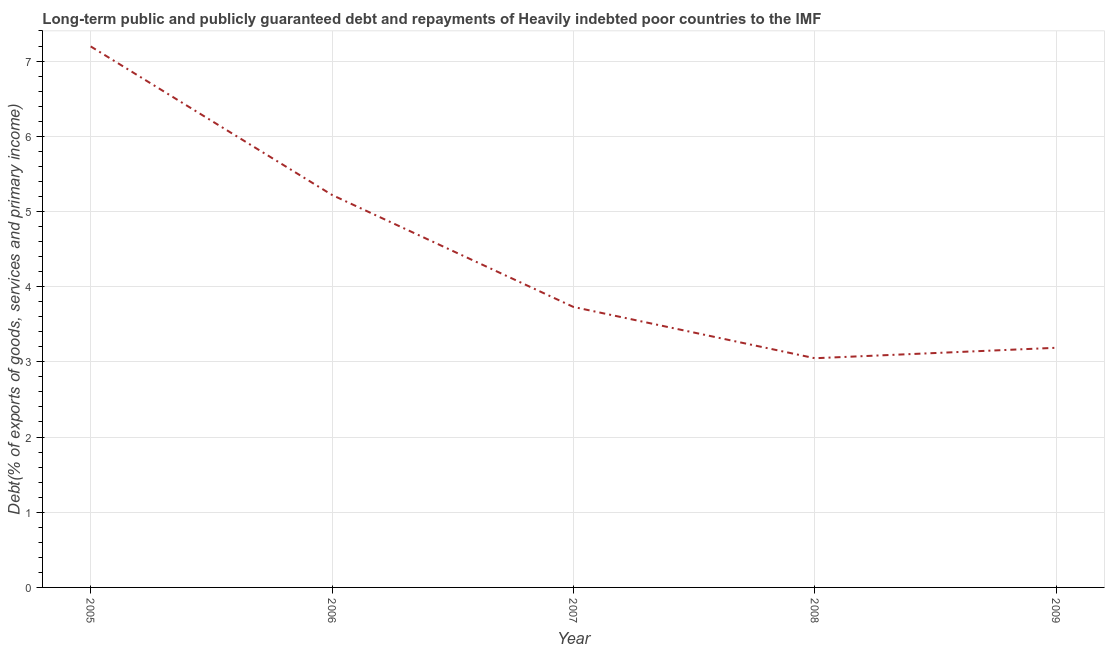What is the debt service in 2005?
Offer a very short reply. 7.19. Across all years, what is the maximum debt service?
Offer a terse response. 7.19. Across all years, what is the minimum debt service?
Make the answer very short. 3.05. What is the sum of the debt service?
Provide a short and direct response. 22.38. What is the difference between the debt service in 2005 and 2009?
Ensure brevity in your answer.  4.01. What is the average debt service per year?
Keep it short and to the point. 4.48. What is the median debt service?
Offer a very short reply. 3.73. In how many years, is the debt service greater than 3.8 %?
Your answer should be compact. 2. Do a majority of the years between 2006 and 2007 (inclusive) have debt service greater than 3.6 %?
Give a very brief answer. Yes. What is the ratio of the debt service in 2006 to that in 2007?
Offer a terse response. 1.4. What is the difference between the highest and the second highest debt service?
Provide a short and direct response. 1.98. What is the difference between the highest and the lowest debt service?
Make the answer very short. 4.15. Does the debt service monotonically increase over the years?
Provide a short and direct response. No. What is the difference between two consecutive major ticks on the Y-axis?
Offer a very short reply. 1. Are the values on the major ticks of Y-axis written in scientific E-notation?
Provide a succinct answer. No. Does the graph contain grids?
Offer a terse response. Yes. What is the title of the graph?
Keep it short and to the point. Long-term public and publicly guaranteed debt and repayments of Heavily indebted poor countries to the IMF. What is the label or title of the X-axis?
Make the answer very short. Year. What is the label or title of the Y-axis?
Keep it short and to the point. Debt(% of exports of goods, services and primary income). What is the Debt(% of exports of goods, services and primary income) of 2005?
Your answer should be compact. 7.19. What is the Debt(% of exports of goods, services and primary income) in 2006?
Ensure brevity in your answer.  5.22. What is the Debt(% of exports of goods, services and primary income) of 2007?
Give a very brief answer. 3.73. What is the Debt(% of exports of goods, services and primary income) in 2008?
Provide a short and direct response. 3.05. What is the Debt(% of exports of goods, services and primary income) of 2009?
Keep it short and to the point. 3.19. What is the difference between the Debt(% of exports of goods, services and primary income) in 2005 and 2006?
Ensure brevity in your answer.  1.98. What is the difference between the Debt(% of exports of goods, services and primary income) in 2005 and 2007?
Provide a succinct answer. 3.46. What is the difference between the Debt(% of exports of goods, services and primary income) in 2005 and 2008?
Offer a terse response. 4.15. What is the difference between the Debt(% of exports of goods, services and primary income) in 2005 and 2009?
Offer a very short reply. 4.01. What is the difference between the Debt(% of exports of goods, services and primary income) in 2006 and 2007?
Provide a short and direct response. 1.49. What is the difference between the Debt(% of exports of goods, services and primary income) in 2006 and 2008?
Provide a short and direct response. 2.17. What is the difference between the Debt(% of exports of goods, services and primary income) in 2006 and 2009?
Offer a terse response. 2.03. What is the difference between the Debt(% of exports of goods, services and primary income) in 2007 and 2008?
Keep it short and to the point. 0.68. What is the difference between the Debt(% of exports of goods, services and primary income) in 2007 and 2009?
Keep it short and to the point. 0.54. What is the difference between the Debt(% of exports of goods, services and primary income) in 2008 and 2009?
Your answer should be compact. -0.14. What is the ratio of the Debt(% of exports of goods, services and primary income) in 2005 to that in 2006?
Give a very brief answer. 1.38. What is the ratio of the Debt(% of exports of goods, services and primary income) in 2005 to that in 2007?
Provide a short and direct response. 1.93. What is the ratio of the Debt(% of exports of goods, services and primary income) in 2005 to that in 2008?
Offer a terse response. 2.36. What is the ratio of the Debt(% of exports of goods, services and primary income) in 2005 to that in 2009?
Keep it short and to the point. 2.26. What is the ratio of the Debt(% of exports of goods, services and primary income) in 2006 to that in 2007?
Give a very brief answer. 1.4. What is the ratio of the Debt(% of exports of goods, services and primary income) in 2006 to that in 2008?
Make the answer very short. 1.71. What is the ratio of the Debt(% of exports of goods, services and primary income) in 2006 to that in 2009?
Make the answer very short. 1.64. What is the ratio of the Debt(% of exports of goods, services and primary income) in 2007 to that in 2008?
Ensure brevity in your answer.  1.22. What is the ratio of the Debt(% of exports of goods, services and primary income) in 2007 to that in 2009?
Your response must be concise. 1.17. What is the ratio of the Debt(% of exports of goods, services and primary income) in 2008 to that in 2009?
Keep it short and to the point. 0.96. 